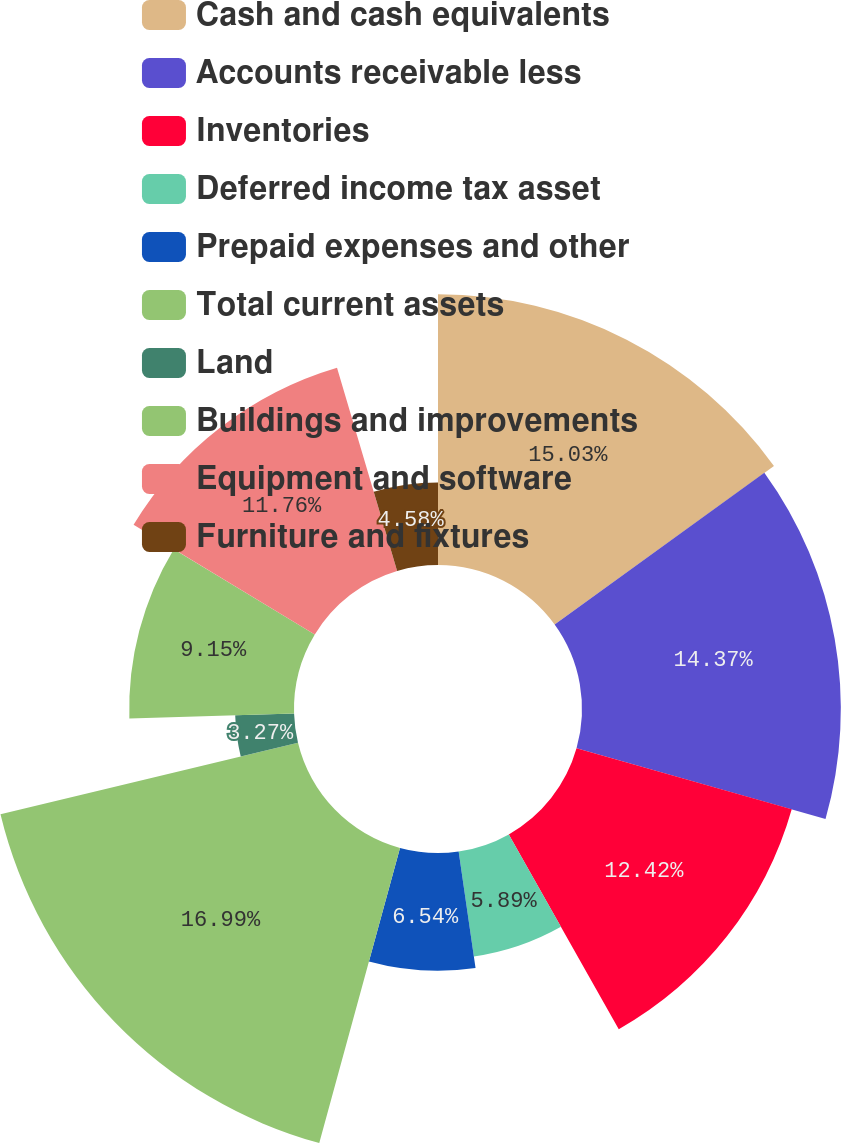Convert chart. <chart><loc_0><loc_0><loc_500><loc_500><pie_chart><fcel>Cash and cash equivalents<fcel>Accounts receivable less<fcel>Inventories<fcel>Deferred income tax asset<fcel>Prepaid expenses and other<fcel>Total current assets<fcel>Land<fcel>Buildings and improvements<fcel>Equipment and software<fcel>Furniture and fixtures<nl><fcel>15.03%<fcel>14.37%<fcel>12.42%<fcel>5.89%<fcel>6.54%<fcel>16.99%<fcel>3.27%<fcel>9.15%<fcel>11.76%<fcel>4.58%<nl></chart> 